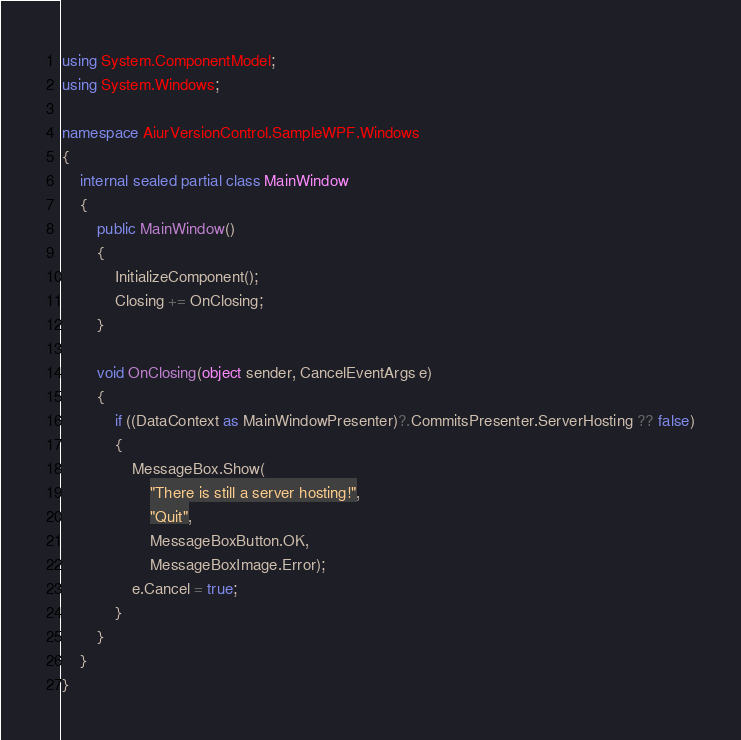Convert code to text. <code><loc_0><loc_0><loc_500><loc_500><_C#_>using System.ComponentModel;
using System.Windows;

namespace AiurVersionControl.SampleWPF.Windows
{
    internal sealed partial class MainWindow
    {
        public MainWindow()
        {
            InitializeComponent();
            Closing += OnClosing;
        }

        void OnClosing(object sender, CancelEventArgs e)
        {
            if ((DataContext as MainWindowPresenter)?.CommitsPresenter.ServerHosting ?? false)
            {
                MessageBox.Show(
                    "There is still a server hosting!",
                    "Quit",
                    MessageBoxButton.OK,
                    MessageBoxImage.Error);
                e.Cancel = true;
            }
        }
    }
}</code> 